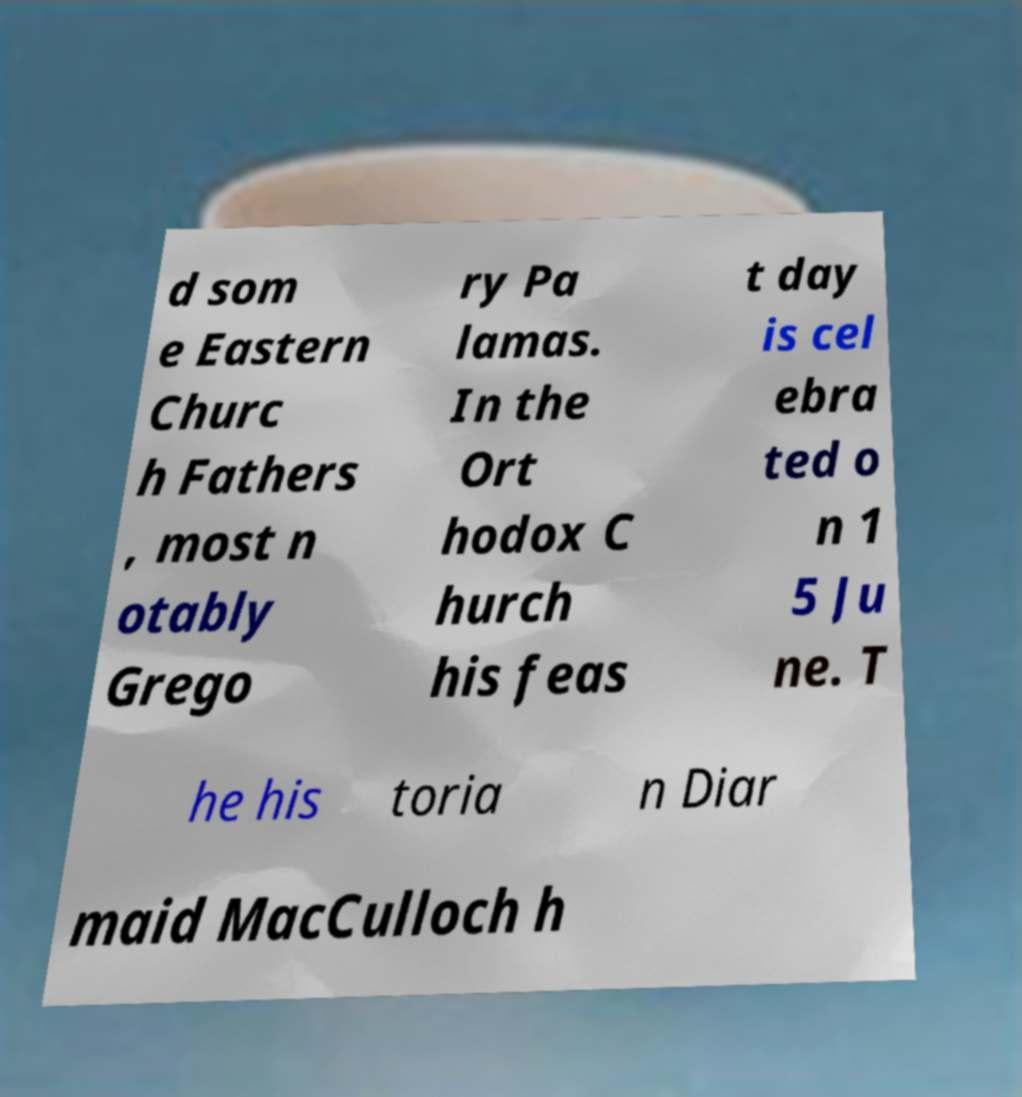Could you assist in decoding the text presented in this image and type it out clearly? d som e Eastern Churc h Fathers , most n otably Grego ry Pa lamas. In the Ort hodox C hurch his feas t day is cel ebra ted o n 1 5 Ju ne. T he his toria n Diar maid MacCulloch h 